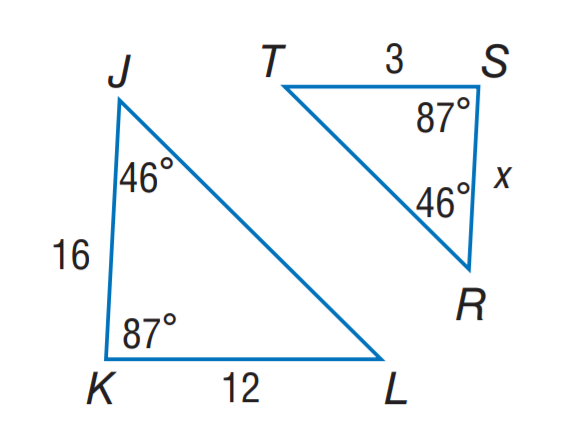Question: Find S R.
Choices:
A. 3
B. 4
C. 5
D. 6
Answer with the letter. Answer: B 